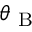<formula> <loc_0><loc_0><loc_500><loc_500>\theta _ { B }</formula> 